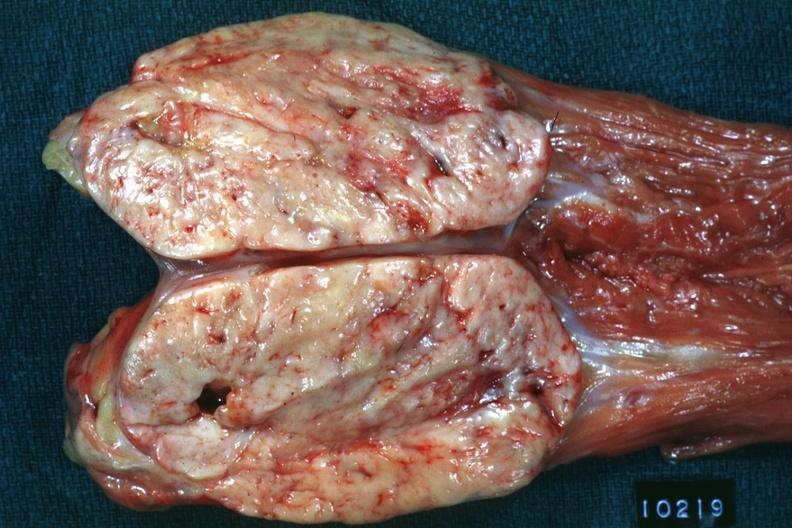what is present?
Answer the question using a single word or phrase. Peritoneum 